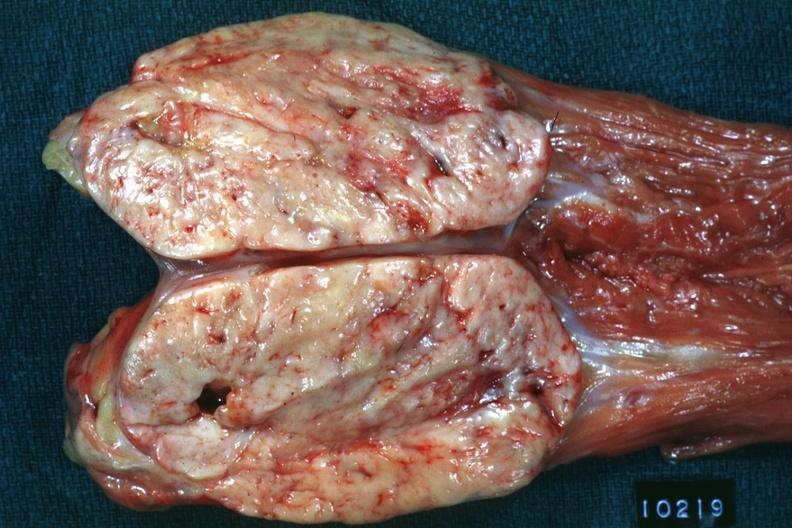what is present?
Answer the question using a single word or phrase. Peritoneum 